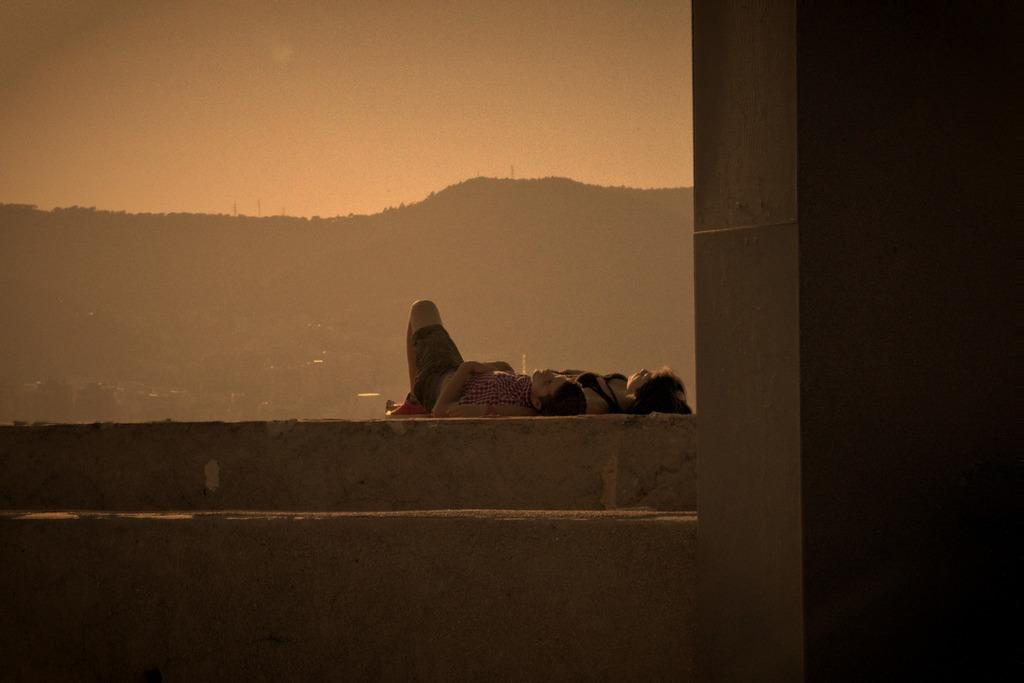What are the two people doing in the image? The two people are lying on the wall. What can be seen in the background of the image? Mountains and the sky are visible in the background. How many jellyfish are swimming in the sky in the image? There are no jellyfish present in the image, and the sky is not a body of water where jellyfish would be found. 